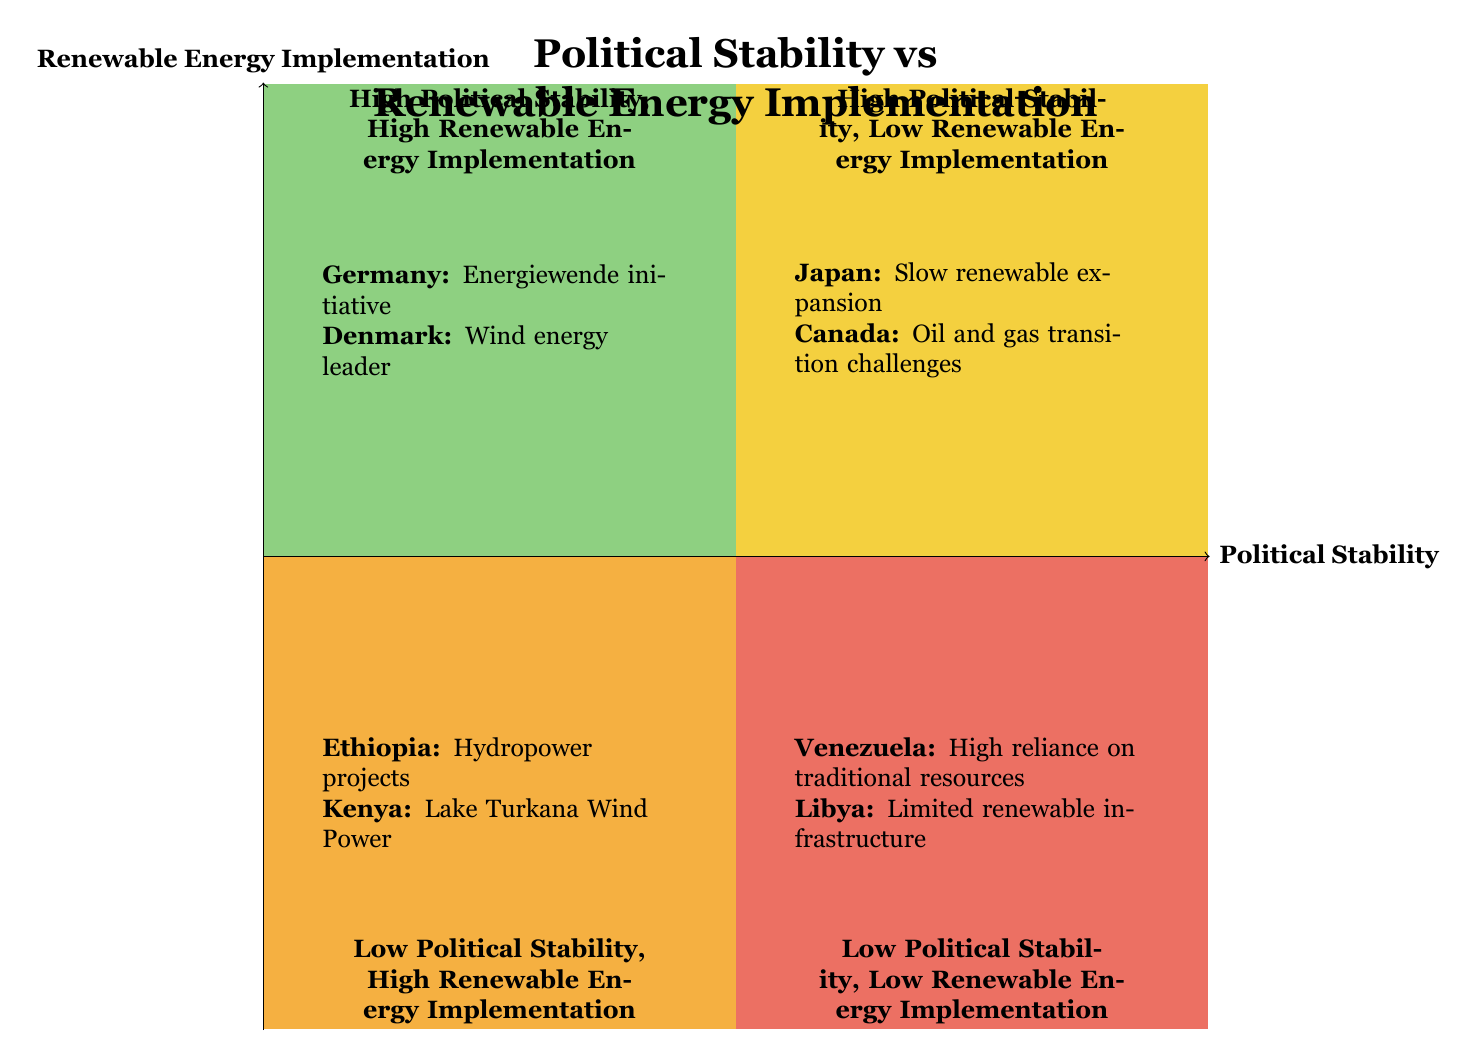What country exemplifies high political stability and high renewable energy implementation? Looking at the quadrant labeled "High Political Stability, High Renewable Energy Implementation," Germany and Denmark are listed as examples. Therefore, Germany is one of the countries that exemplifies both high political stability and implementation of renewable energy.
Answer: Germany Which quadrant contains countries with low political stability and low renewable energy implementation? The quadrant labeled "Low Political Stability, Low Renewable Energy Implementation" contains countries that are characterized by both low political stability and a lack of renewable energy initiatives. This quadrant specifically mentions Venezuela and Libya.
Answer: Low Political Stability, Low Renewable Energy Implementation What is a characteristic of Canada in relation to renewable energy? In the quadrant labeled "High Political Stability, Low Renewable Energy Implementation," Canada is described as facing challenges in transitioning away from its oil and gas sectors towards renewable energy despite maintaining political stability.
Answer: Challenges in transitioning from oil and gas Which countries are leading in renewable energy projects despite low political stability? The quadrant labeled "Low Political Stability, High Renewable Energy Implementation" includes Ethiopia and Kenya, which are recognized for their significant renewable energy projects despite facing political instability.
Answer: Ethiopia and Kenya How many quadrants are represented in this diagram? The diagram is divided into four distinct quadrants, each reflecting different combinations of political stability and renewable energy implementation.
Answer: Four quadrants What is the main political challenge that Japan faces regarding renewable energy implementation? Japan is situated in the "High Political Stability, Low Renewable Energy Implementation" quadrant, where it is noted that its renewable energy expansion has been slow due to a focus on nuclear power and fossil fuels. This indicates that the main challenge is its reliance on these energy sources.
Answer: Focus on nuclear power and fossil fuels Which quadrant indicates the highest level of renewable energy implementation? The quadrant named "High Political Stability, High Renewable Energy Implementation" indicates the highest level of renewable energy project implementation, showcasing countries like Germany and Denmark.
Answer: High Political Stability, High Renewable Energy Implementation What does Ethiopia's renewable energy focus represent in the diagram? In the "Low Political Stability, High Renewable Energy Implementation" quadrant, Ethiopia's focus on hydropower projects represents a significant effort to implement renewable energy despite its political instability, highlighting an unusual correlation.
Answer: Hydropower projects 